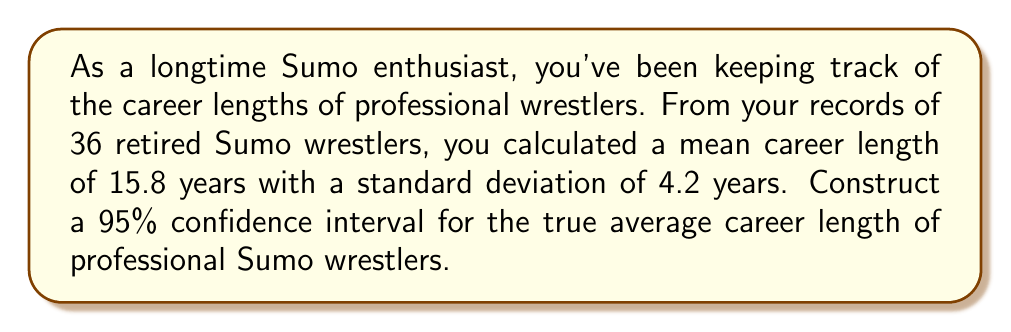Can you answer this question? Let's approach this step-by-step:

1) We are dealing with a sample mean and want to estimate the population mean. This calls for a confidence interval for the mean.

2) Given information:
   - Sample size: $n = 36$
   - Sample mean: $\bar{x} = 15.8$ years
   - Sample standard deviation: $s = 4.2$ years
   - Confidence level: 95%

3) The formula for the confidence interval is:

   $$\bar{x} \pm t_{\alpha/2} \cdot \frac{s}{\sqrt{n}}$$

   where $t_{\alpha/2}$ is the t-value for the given confidence level and degrees of freedom.

4) Degrees of freedom: $df = n - 1 = 36 - 1 = 35$

5) For a 95% confidence interval, $\alpha = 0.05$, and $\alpha/2 = 0.025$

6) From the t-distribution table, with $df = 35$ and $\alpha/2 = 0.025$, we find $t_{\alpha/2} \approx 2.030$

7) Now we can calculate the margin of error:

   $$\text{Margin of Error} = t_{\alpha/2} \cdot \frac{s}{\sqrt{n}} = 2.030 \cdot \frac{4.2}{\sqrt{36}} \approx 1.42$$

8) Therefore, the confidence interval is:

   $$15.8 \pm 1.42$$

   Which gives us the interval $(14.38, 17.22)$
Answer: (14.38, 17.22) years 